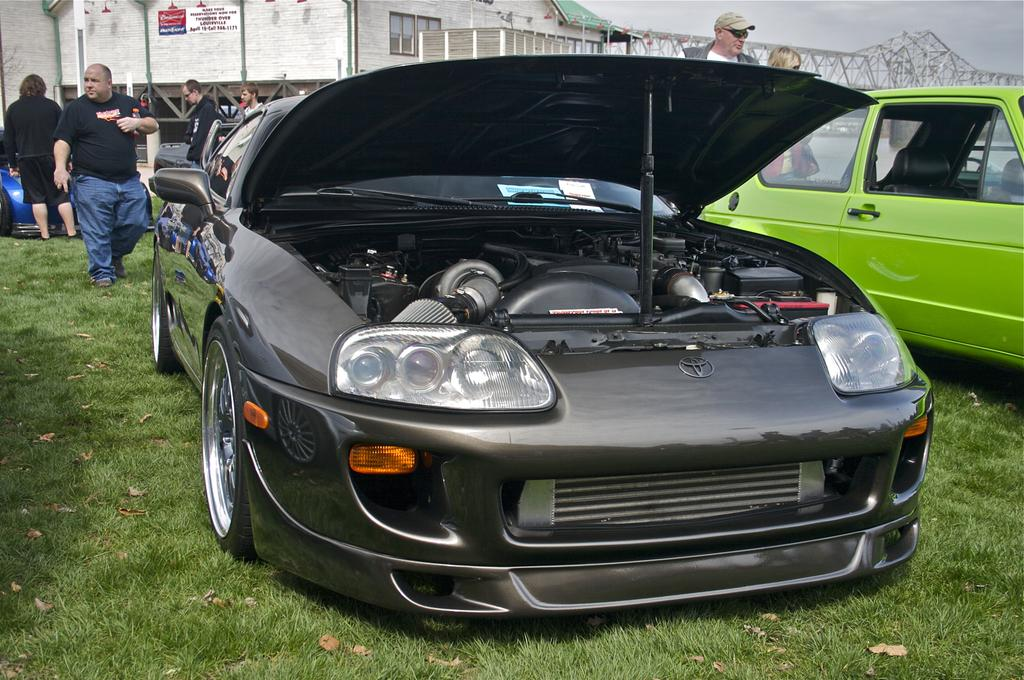Who or what can be seen in the image? There are people in the image. What else is present in the image besides people? There are vehicles and a building in the image. Can you describe any specific features of the image? There is a bridge in the image, and the sky is visible in the background. What is the value of the beetle in the image? There is no beetle present in the image, so it is not possible to determine its value. 